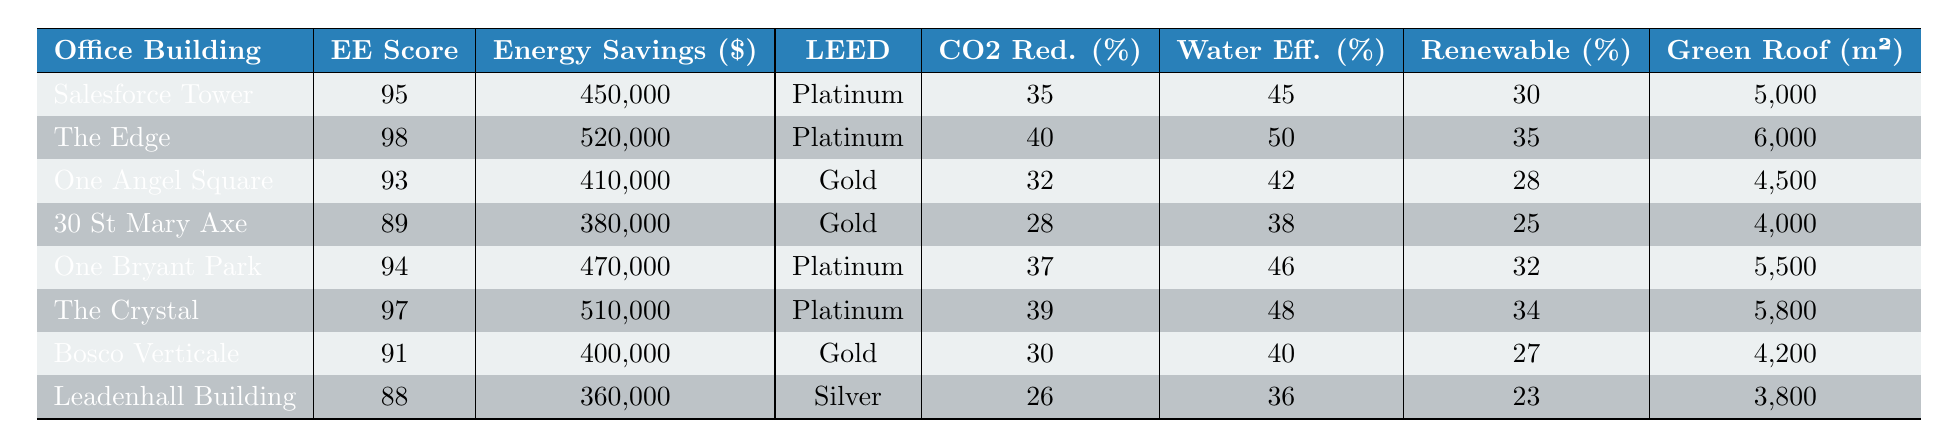What is the energy efficiency score of The Edge? The table shows that The Edge has an energy efficiency score listed in the second column. The score is 98.
Answer: 98 Which office building has the highest annual energy savings? To find the highest annual energy savings, we look at the energy savings column and identify the maximum value, which is 520,000 for The Edge.
Answer: The Edge Does Leadenhall Building have LEED certification? The LEED certification status for Leadenhall Building is shown in the corresponding column. It is listed as Silver validation.
Answer: Yes What is the average energy efficiency score of all the buildings listed? To find the average, first, we sum the energy efficiency scores: 95 + 98 + 93 + 89 + 94 + 97 + 91 + 88 = 785. Then, we divide by the number of buildings, which is 8: 785/8 = 98.125.
Answer: 98.125 Is the renewable energy usage of One Bryant Park greater than 30%? The table shows that the renewable energy usage for One Bryant Park is 32%, which is indeed greater than 30%.
Answer: Yes Which building has both Platinum LEED certification and the highest CO2 reduction percentage? The table shows that The Edge and Salesforce Tower both have Platinum LEED certification. Among them, The Edge has a CO2 reduction percentage of 40%, which is the highest.
Answer: The Edge What is the difference in annual energy savings between Salesforce Tower and 30 St Mary Axe? We look at the annual energy savings for both buildings: Salesforce Tower has 450,000 and 30 St Mary Axe has 380,000. The difference is 450,000 - 380,000 = 70,000.
Answer: 70,000 Which building has the least water efficiency percentage? By examining the water efficiency percentages, we find that Leadenhall Building has the least at 36%.
Answer: Leadenhall Building If the green roof area of Bosco Verticale is added to One Bryant Park, what will the total green roof area be? The green roof area for Bosco Verticale is 4,200 m², and for One Bryant Park, it is 5,500 m². Therefore, 4,200 + 5,500 = 9,700 m².
Answer: 9,700 m² How many buildings have a CO2 reduction of 30% or higher? We count the CO2 reduction percentages from the table: The Edge (40%), The Crystal (39%), One Bryant Park (37%), and Salesforce Tower (35%). This adds up to 4 buildings.
Answer: 4 